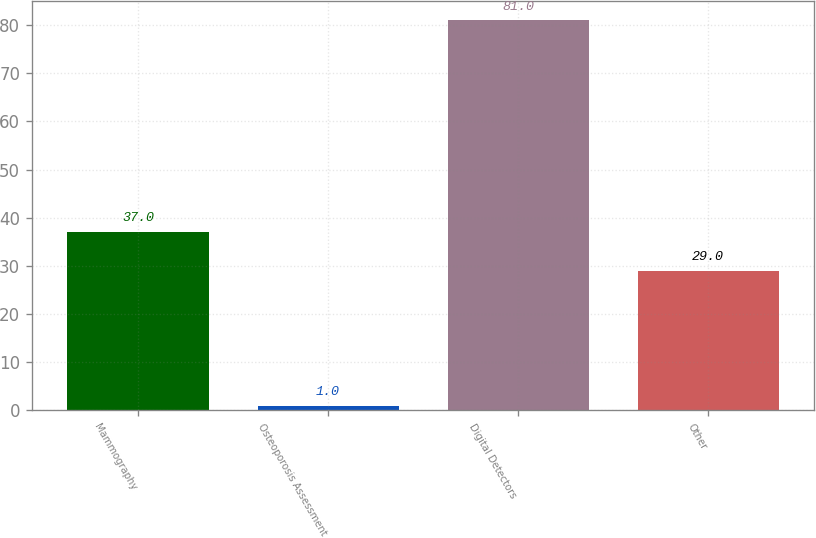Convert chart to OTSL. <chart><loc_0><loc_0><loc_500><loc_500><bar_chart><fcel>Mammography<fcel>Osteoporosis Assessment<fcel>Digital Detectors<fcel>Other<nl><fcel>37<fcel>1<fcel>81<fcel>29<nl></chart> 